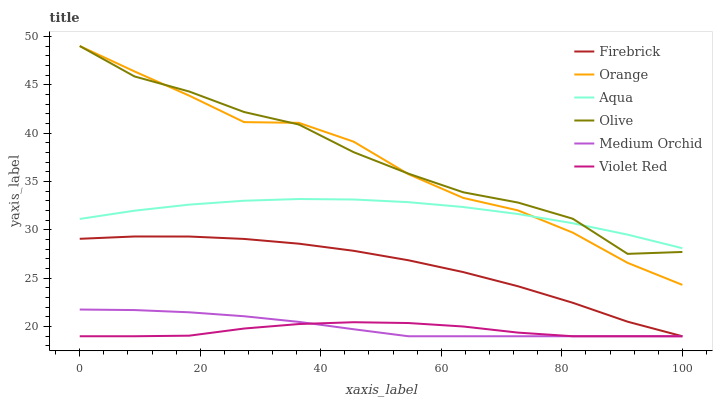Does Violet Red have the minimum area under the curve?
Answer yes or no. Yes. Does Olive have the maximum area under the curve?
Answer yes or no. Yes. Does Firebrick have the minimum area under the curve?
Answer yes or no. No. Does Firebrick have the maximum area under the curve?
Answer yes or no. No. Is Medium Orchid the smoothest?
Answer yes or no. Yes. Is Olive the roughest?
Answer yes or no. Yes. Is Firebrick the smoothest?
Answer yes or no. No. Is Firebrick the roughest?
Answer yes or no. No. Does Violet Red have the lowest value?
Answer yes or no. Yes. Does Aqua have the lowest value?
Answer yes or no. No. Does Orange have the highest value?
Answer yes or no. Yes. Does Firebrick have the highest value?
Answer yes or no. No. Is Firebrick less than Olive?
Answer yes or no. Yes. Is Olive greater than Violet Red?
Answer yes or no. Yes. Does Olive intersect Aqua?
Answer yes or no. Yes. Is Olive less than Aqua?
Answer yes or no. No. Is Olive greater than Aqua?
Answer yes or no. No. Does Firebrick intersect Olive?
Answer yes or no. No. 